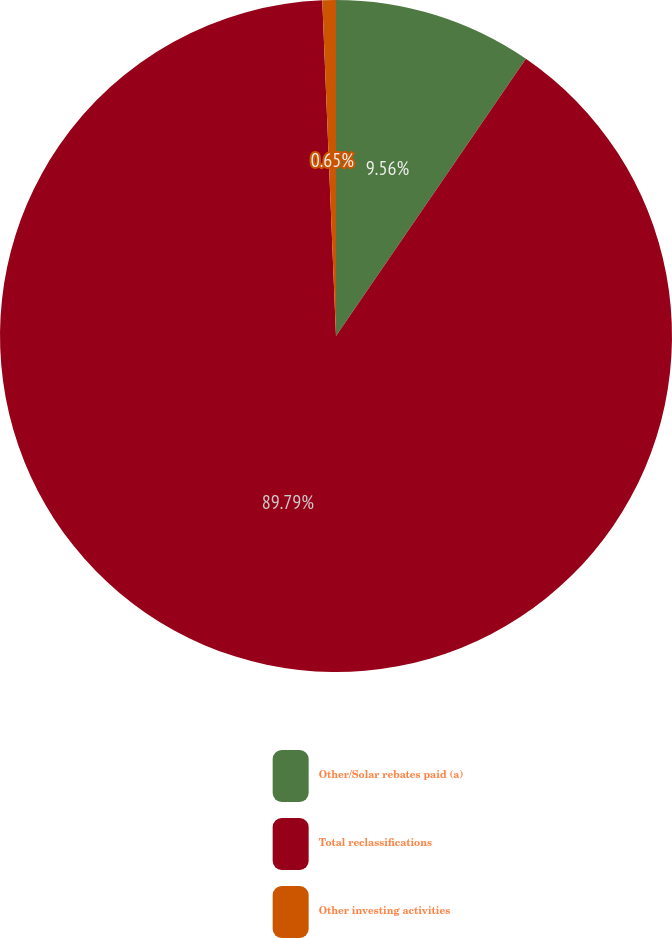Convert chart to OTSL. <chart><loc_0><loc_0><loc_500><loc_500><pie_chart><fcel>Other/Solar rebates paid (a)<fcel>Total reclassifications<fcel>Other investing activities<nl><fcel>9.56%<fcel>89.78%<fcel>0.65%<nl></chart> 